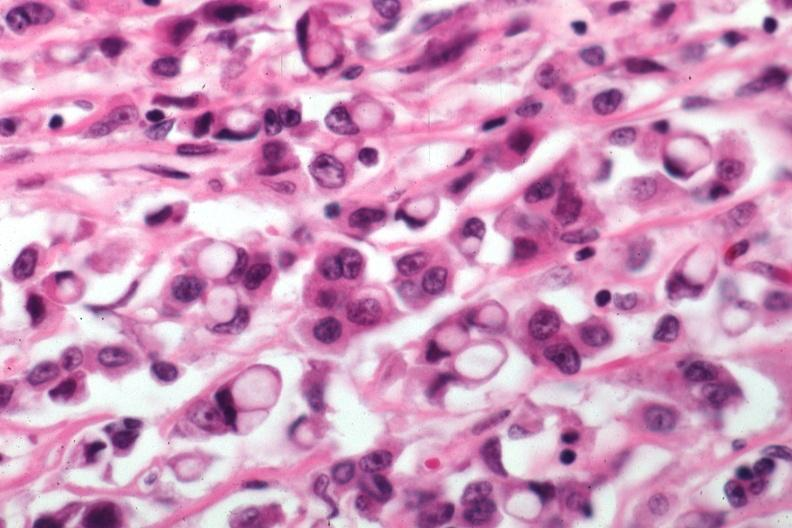what is present?
Answer the question using a single word or phrase. Breast 